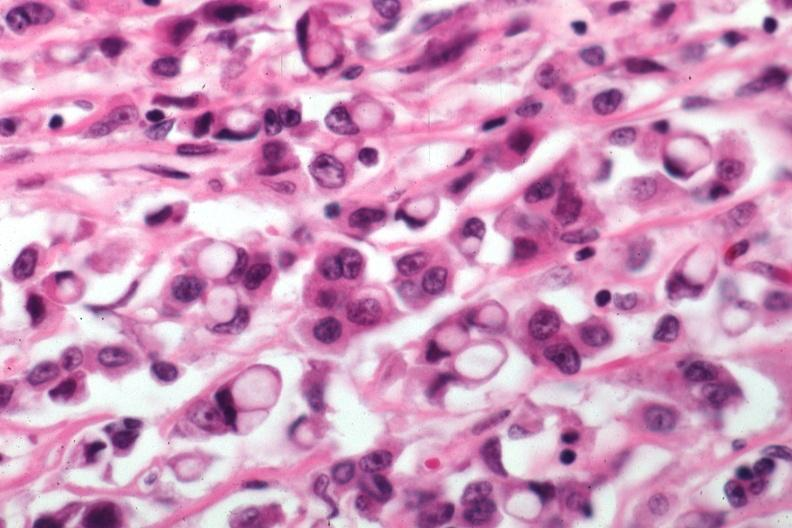what is present?
Answer the question using a single word or phrase. Breast 